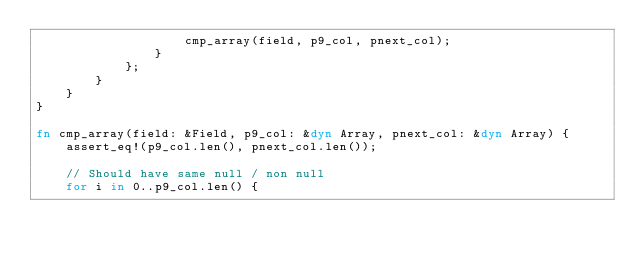Convert code to text. <code><loc_0><loc_0><loc_500><loc_500><_Rust_>                    cmp_array(field, p9_col, pnext_col);
                }
            };
        }
    }
}

fn cmp_array(field: &Field, p9_col: &dyn Array, pnext_col: &dyn Array) {
    assert_eq!(p9_col.len(), pnext_col.len());

    // Should have same null / non null
    for i in 0..p9_col.len() {</code> 